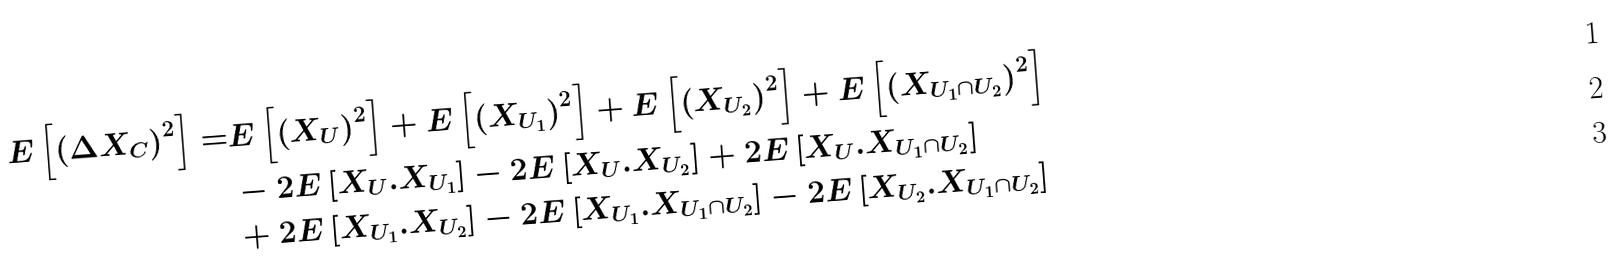Convert formula to latex. <formula><loc_0><loc_0><loc_500><loc_500>E \left [ \left ( \Delta X _ { C } \right ) ^ { 2 } \right ] = & E \left [ \left ( X _ { U } \right ) ^ { 2 } \right ] + E \left [ \left ( X _ { U _ { 1 } } \right ) ^ { 2 } \right ] + E \left [ \left ( X _ { U _ { 2 } } \right ) ^ { 2 } \right ] + E \left [ \left ( X _ { U _ { 1 } \cap U _ { 2 } } \right ) ^ { 2 } \right ] \\ & - 2 E \left [ X _ { U } . X _ { U _ { 1 } } \right ] - 2 E \left [ X _ { U } . X _ { U _ { 2 } } \right ] + 2 E \left [ X _ { U } . X _ { U _ { 1 } \cap U _ { 2 } } \right ] \\ & + 2 E \left [ X _ { U _ { 1 } } . X _ { U _ { 2 } } \right ] - 2 E \left [ X _ { U _ { 1 } } . X _ { U _ { 1 } \cap U _ { 2 } } \right ] - 2 E \left [ X _ { U _ { 2 } } . X _ { U _ { 1 } \cap U _ { 2 } } \right ]</formula> 